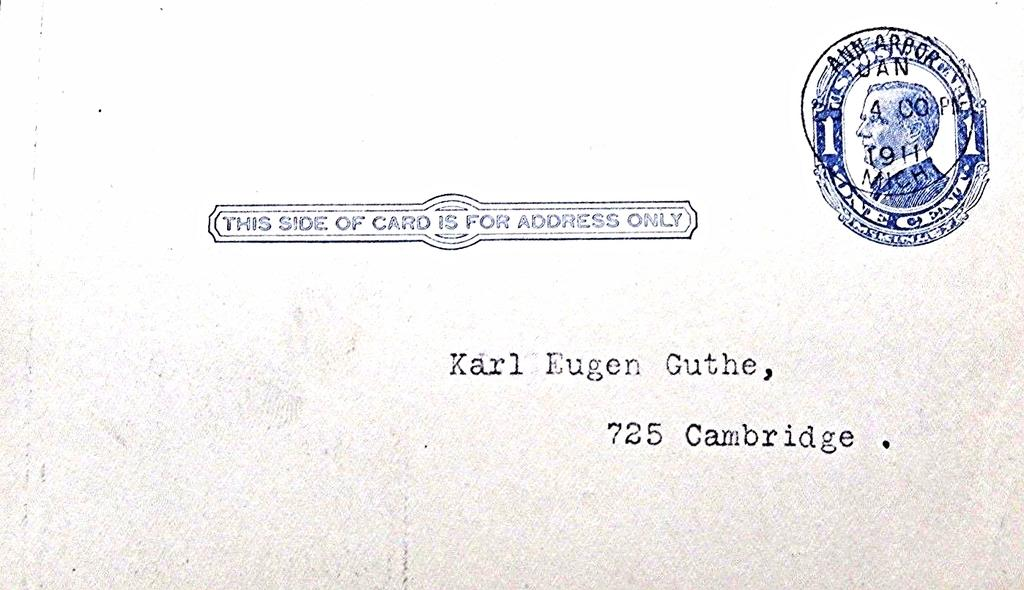<image>
Create a compact narrative representing the image presented. An envelope is shown with the the words this side of card is for address only 